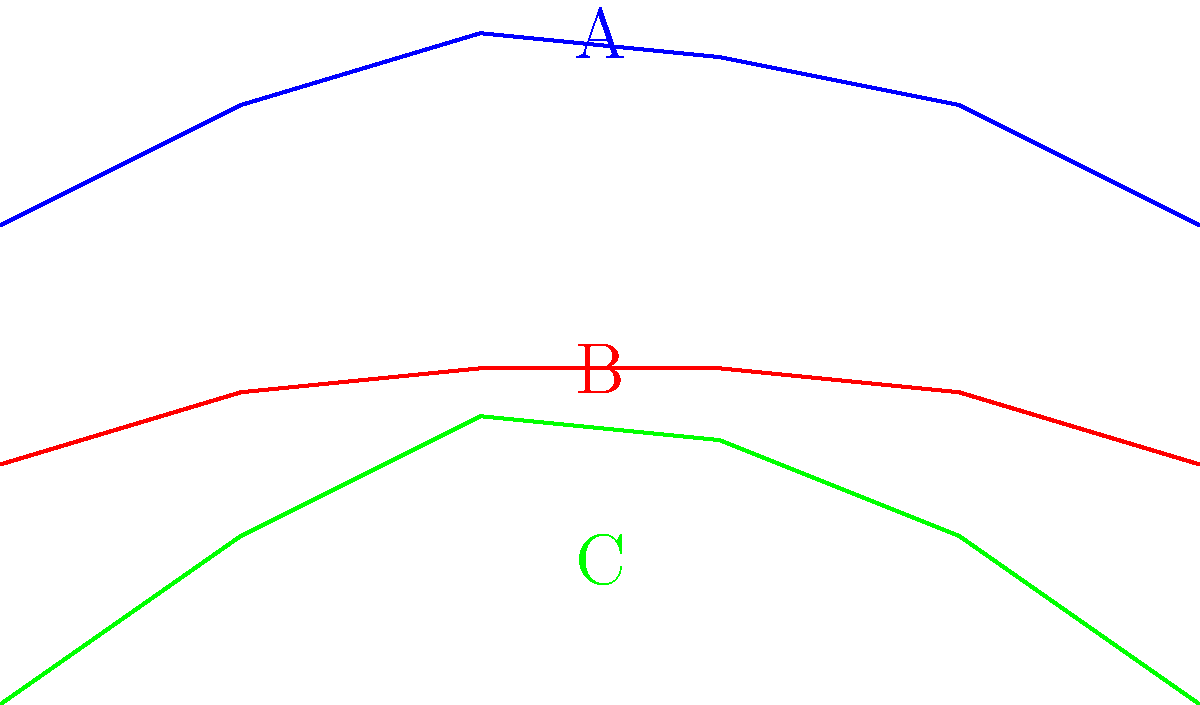Based on the silhouette diagrams of three ski jumper positions (A, B, and C) shown above, which position is likely to provide the best aerodynamic profile for maximizing distance in a ski jump competition? To determine the best aerodynamic profile for maximizing distance in a ski jump, we need to consider the principles of aerodynamics and how they apply to each silhouette:

1. Surface area exposed to air resistance:
   - Position A: Moderate surface area
   - Position B: Lowest surface area
   - Position C: Highest surface area

2. Body positioning:
   - Position A: Slightly curved, moderate streamlining
   - Position B: Flatter, more streamlined
   - Position C: More upright, least streamlined

3. Lift generation:
   - Position A: Moderate lift potential
   - Position B: Some lift potential, but less than A
   - Position C: Highest lift potential, but with significant drag

4. Drag reduction:
   - Position A: Moderate drag reduction
   - Position B: Best drag reduction
   - Position C: Least drag reduction

5. Balance between lift and drag:
   - Position A: Good balance
   - Position B: Favors drag reduction over lift
   - Position C: Favors lift over drag reduction

Considering these factors, Position B provides the best aerodynamic profile for maximizing distance. It offers the lowest surface area exposed to air resistance and the most streamlined body positioning, which significantly reduces drag. While it may generate slightly less lift than Position A, the reduction in drag more than compensates for this, allowing the jumper to maintain speed and achieve greater distances.

Position A is a close second, offering a good balance between lift and drag reduction, but it doesn't minimize drag as effectively as Position B.

Position C, while potentially generating the most lift, creates too much drag and would likely result in a shorter jump distance due to rapid deceleration.
Answer: Position B 